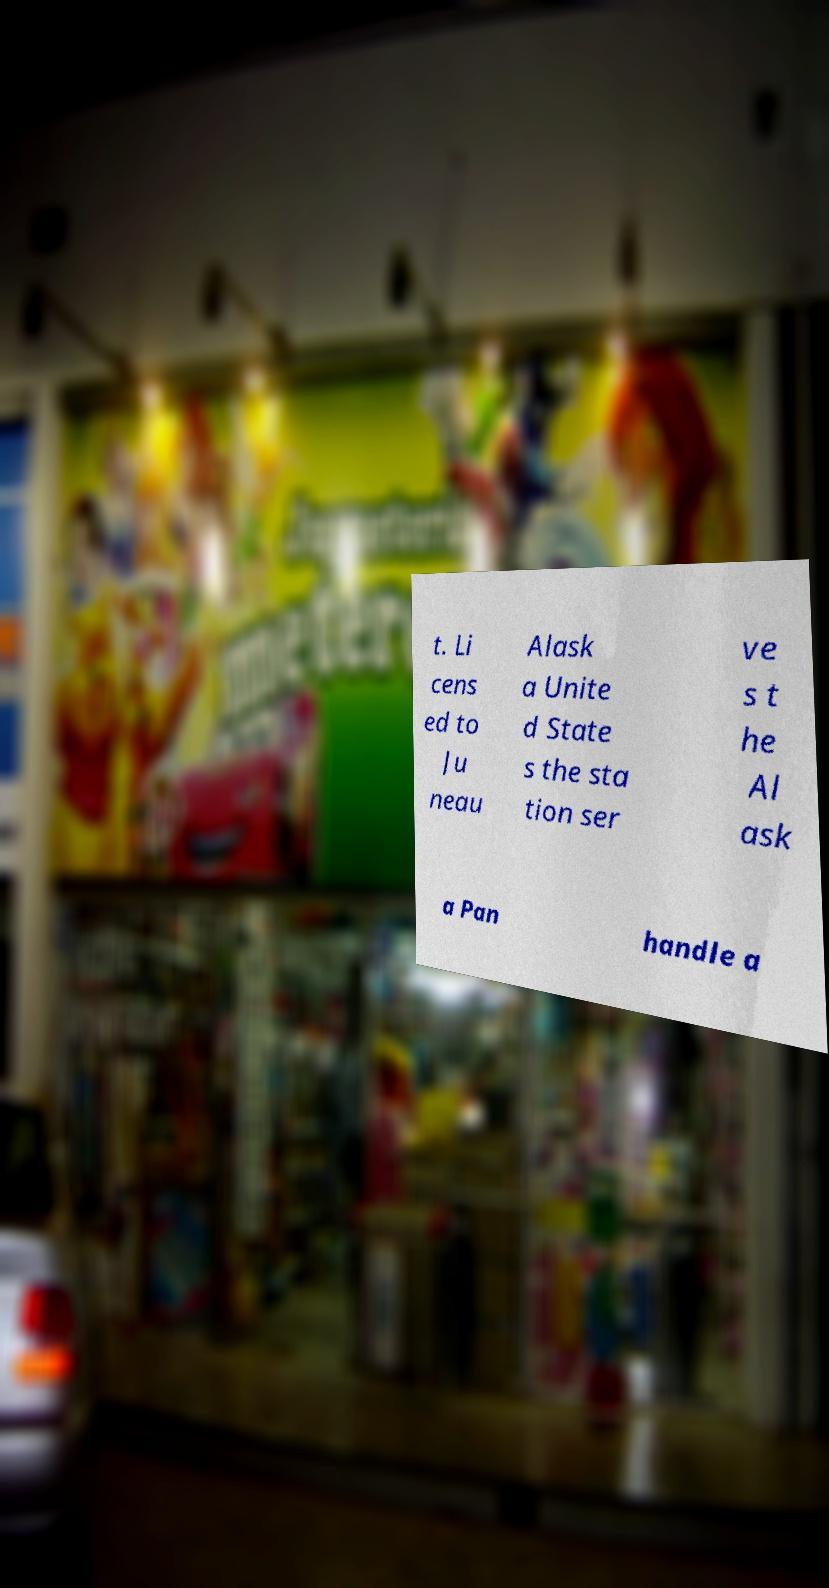What messages or text are displayed in this image? I need them in a readable, typed format. t. Li cens ed to Ju neau Alask a Unite d State s the sta tion ser ve s t he Al ask a Pan handle a 